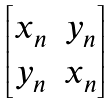<formula> <loc_0><loc_0><loc_500><loc_500>\begin{bmatrix} x _ { n } & y _ { n } \\ y _ { n } & x _ { n } \end{bmatrix}</formula> 